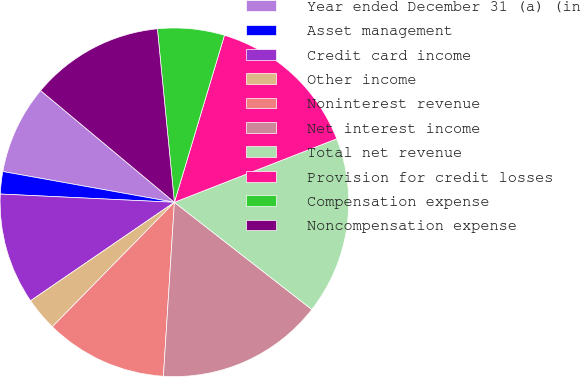Convert chart. <chart><loc_0><loc_0><loc_500><loc_500><pie_chart><fcel>Year ended December 31 (a) (in<fcel>Asset management<fcel>Credit card income<fcel>Other income<fcel>Noninterest revenue<fcel>Net interest income<fcel>Total net revenue<fcel>Provision for credit losses<fcel>Compensation expense<fcel>Noncompensation expense<nl><fcel>8.25%<fcel>2.07%<fcel>10.31%<fcel>3.1%<fcel>11.34%<fcel>15.46%<fcel>16.48%<fcel>14.43%<fcel>6.19%<fcel>12.37%<nl></chart> 